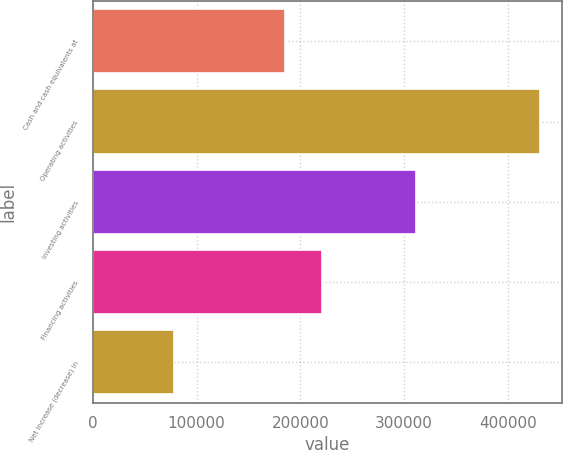<chart> <loc_0><loc_0><loc_500><loc_500><bar_chart><fcel>Cash and cash equivalents at<fcel>Operating activities<fcel>Investing activities<fcel>Financing activities<fcel>Net increase (decrease) in<nl><fcel>185157<fcel>430681<fcel>311397<fcel>220364<fcel>78615<nl></chart> 